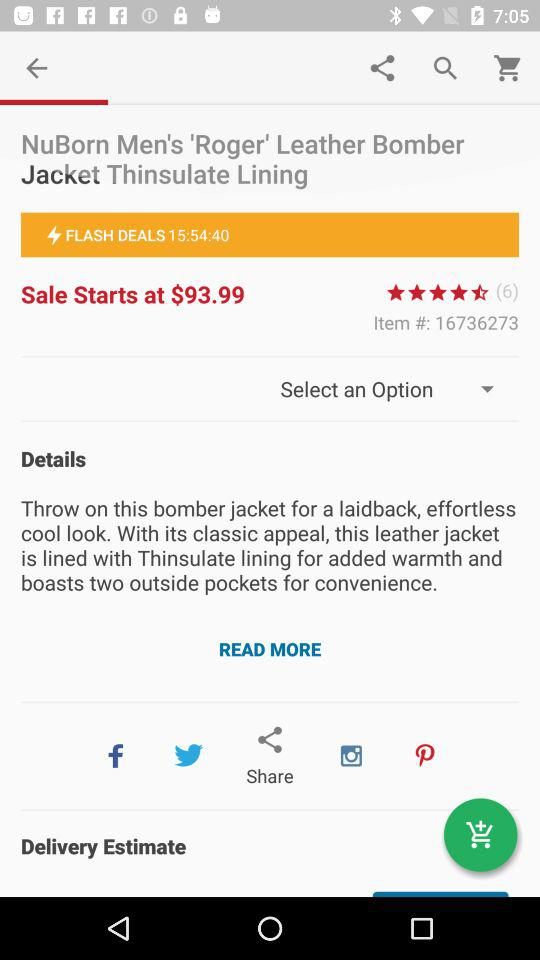After what time will flash deals start? Flash deals will start in 15 hours 54 minutes 40 seconds. 